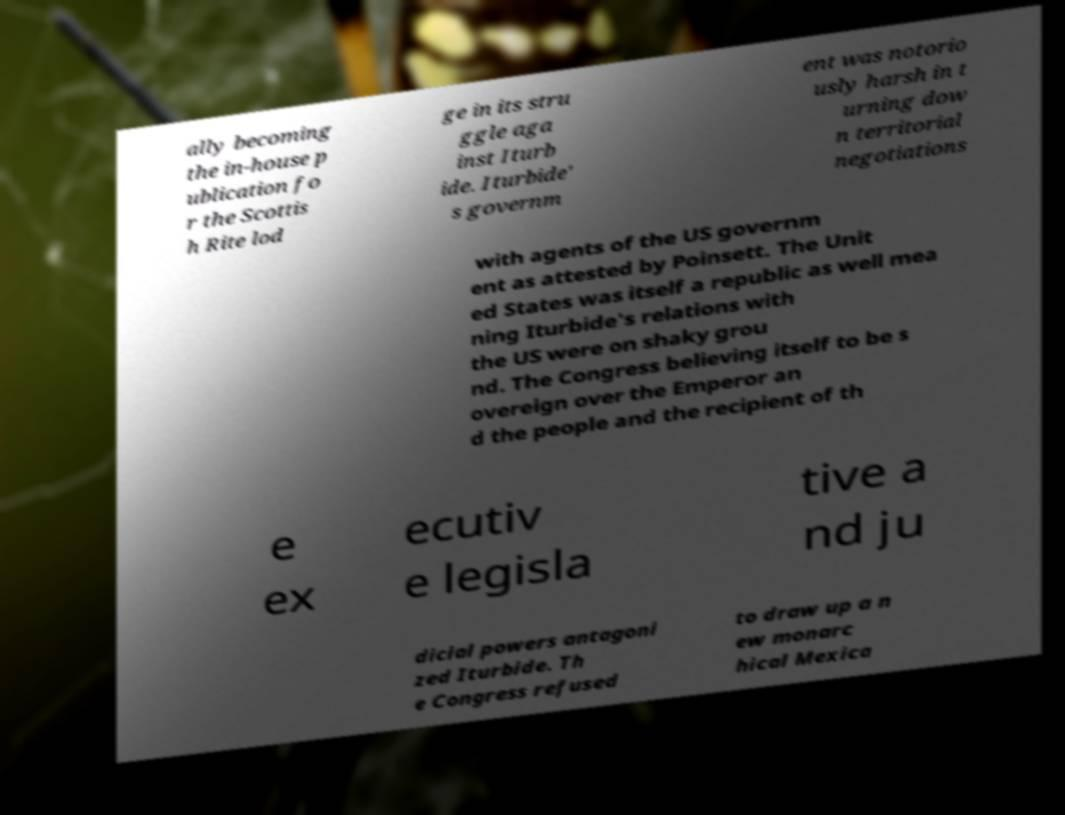Could you extract and type out the text from this image? ally becoming the in-house p ublication fo r the Scottis h Rite lod ge in its stru ggle aga inst Iturb ide. Iturbide' s governm ent was notorio usly harsh in t urning dow n territorial negotiations with agents of the US governm ent as attested by Poinsett. The Unit ed States was itself a republic as well mea ning Iturbide's relations with the US were on shaky grou nd. The Congress believing itself to be s overeign over the Emperor an d the people and the recipient of th e ex ecutiv e legisla tive a nd ju dicial powers antagoni zed Iturbide. Th e Congress refused to draw up a n ew monarc hical Mexica 